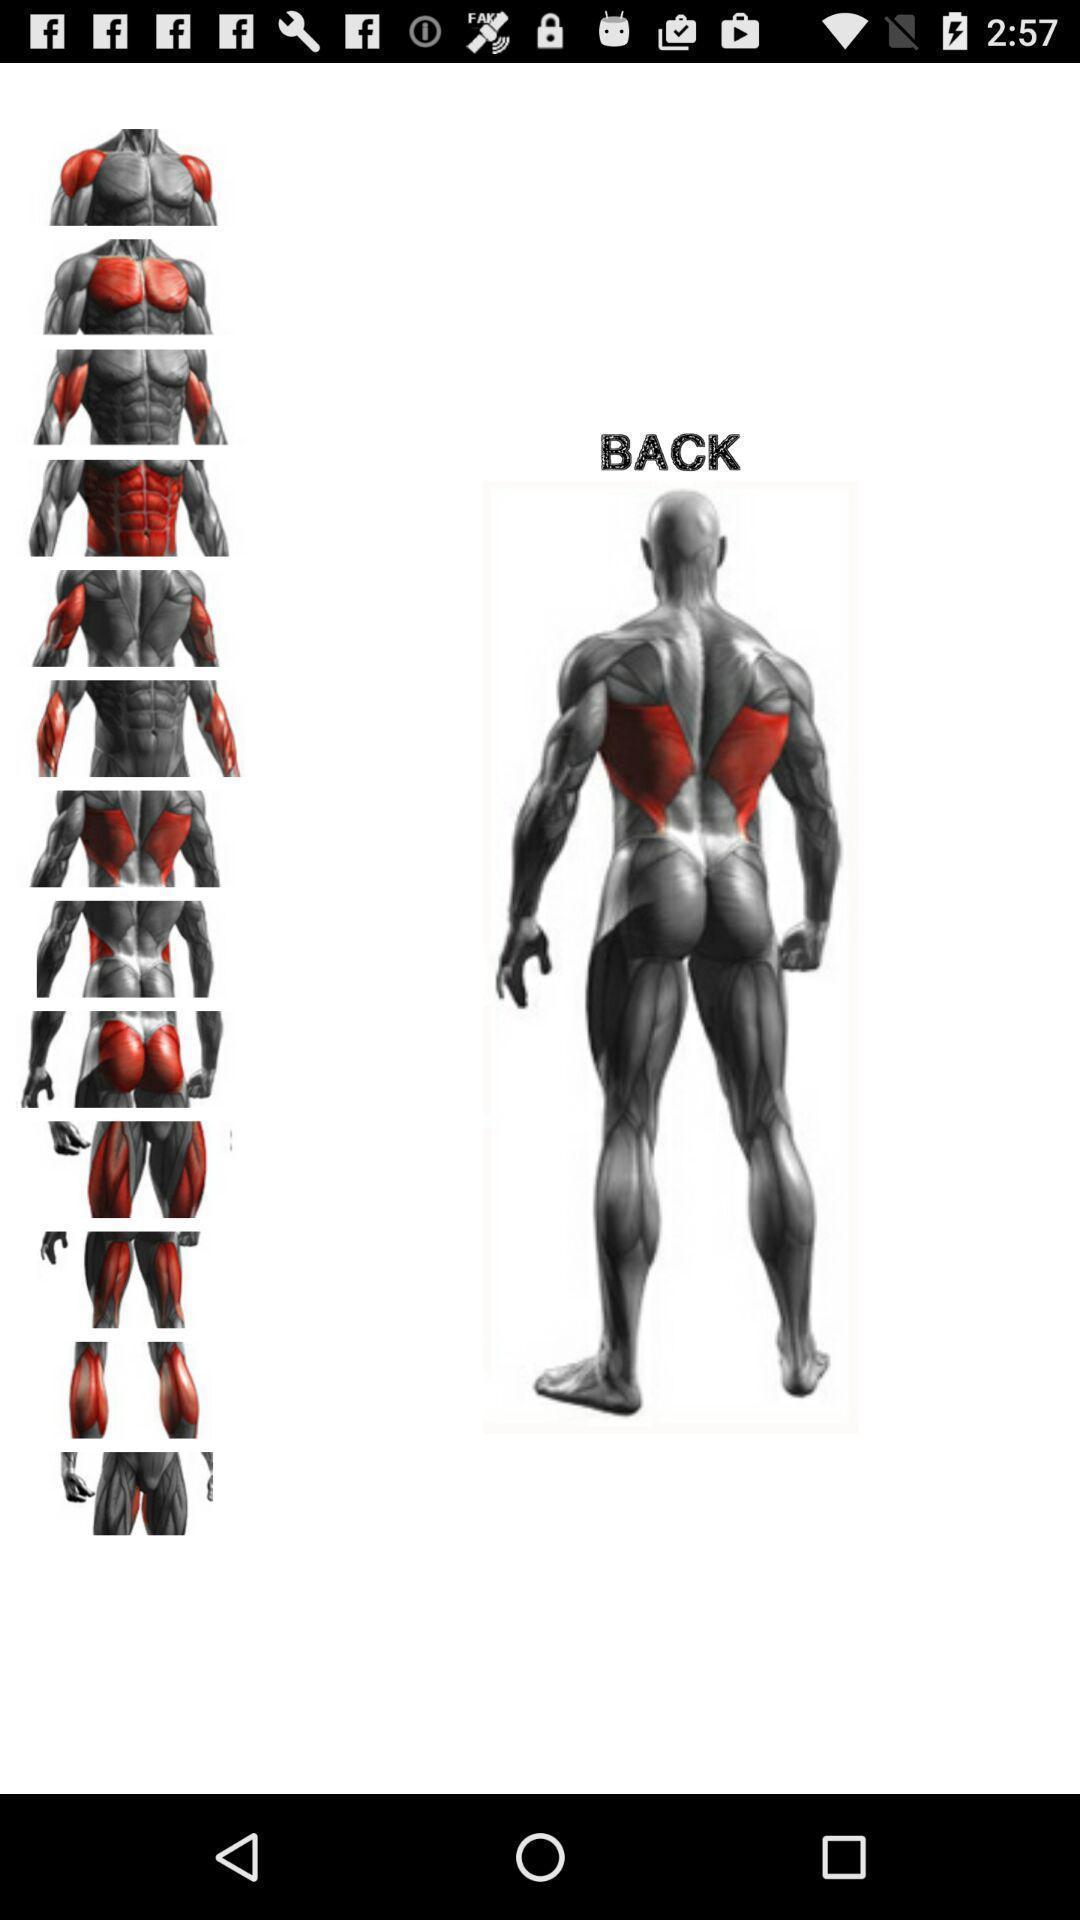Describe the key features of this screenshot. Screen displaying the image of a human body. 